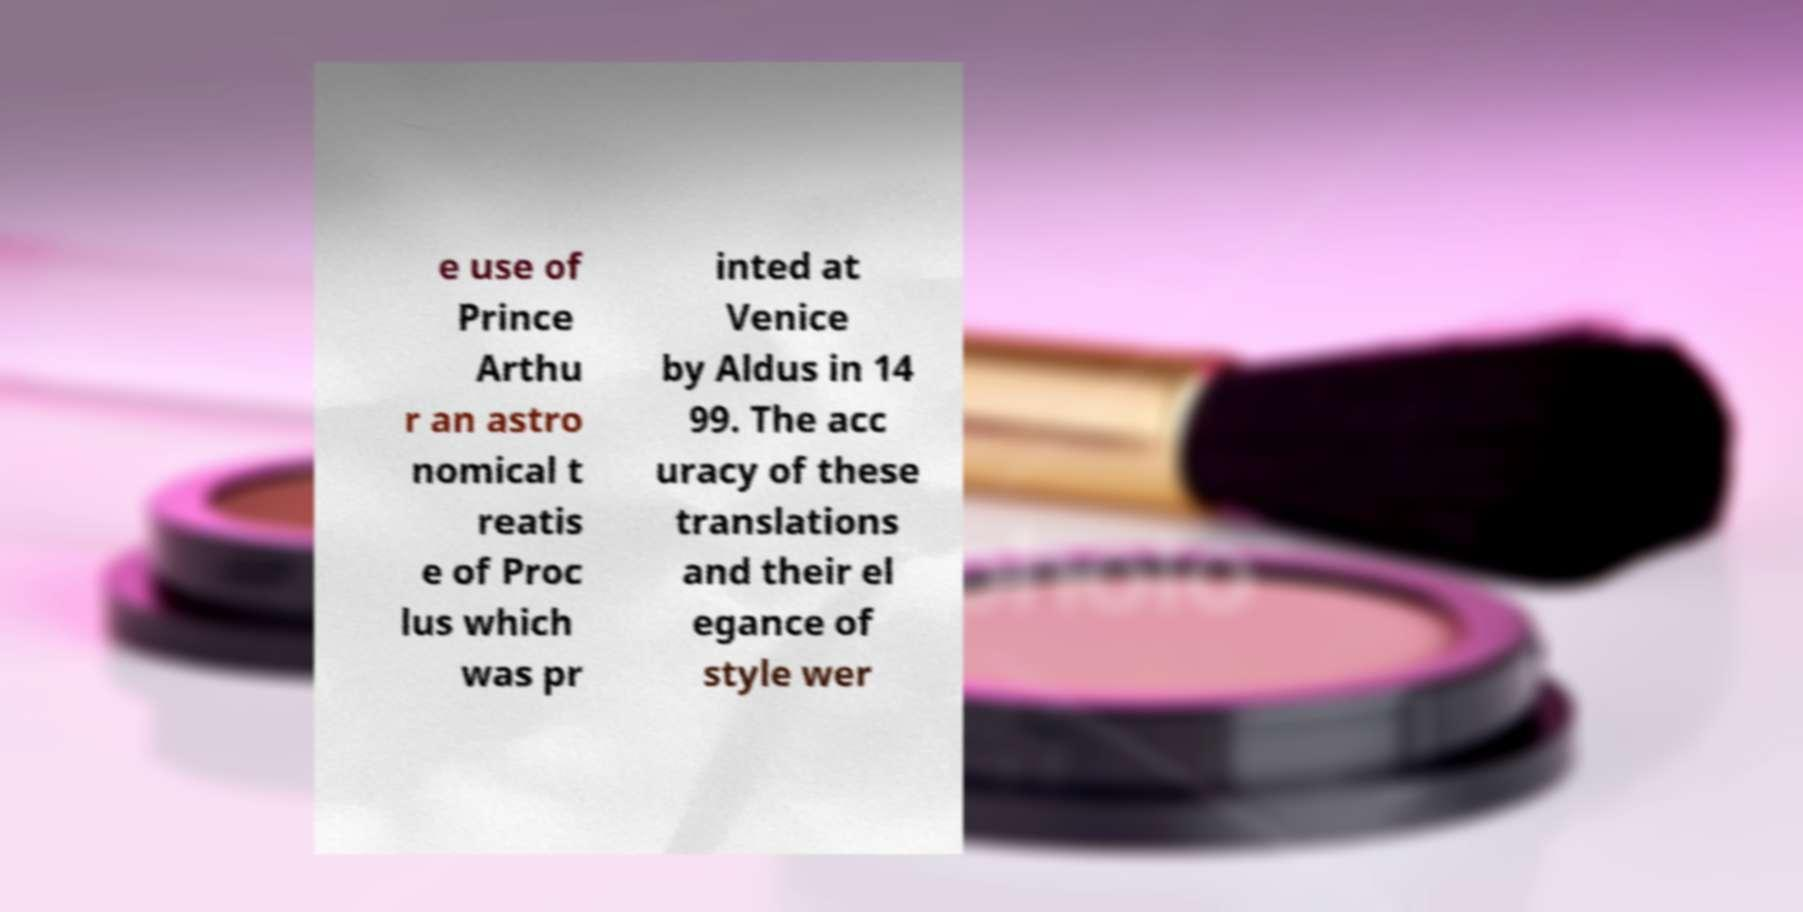Could you extract and type out the text from this image? e use of Prince Arthu r an astro nomical t reatis e of Proc lus which was pr inted at Venice by Aldus in 14 99. The acc uracy of these translations and their el egance of style wer 